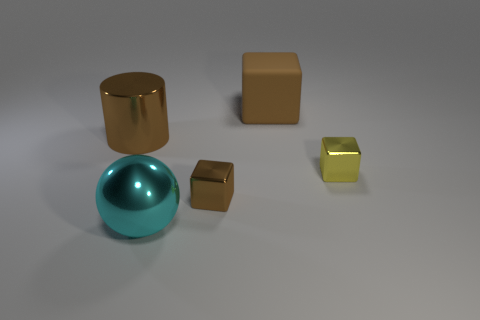Subtract all brown cylinders. How many brown cubes are left? 2 Subtract all small shiny blocks. How many blocks are left? 1 Add 4 big metal balls. How many objects exist? 9 Subtract all cylinders. How many objects are left? 4 Subtract 0 blue balls. How many objects are left? 5 Subtract all green blocks. Subtract all gray balls. How many blocks are left? 3 Subtract all small brown blocks. Subtract all large things. How many objects are left? 1 Add 2 small blocks. How many small blocks are left? 4 Add 5 small gray spheres. How many small gray spheres exist? 5 